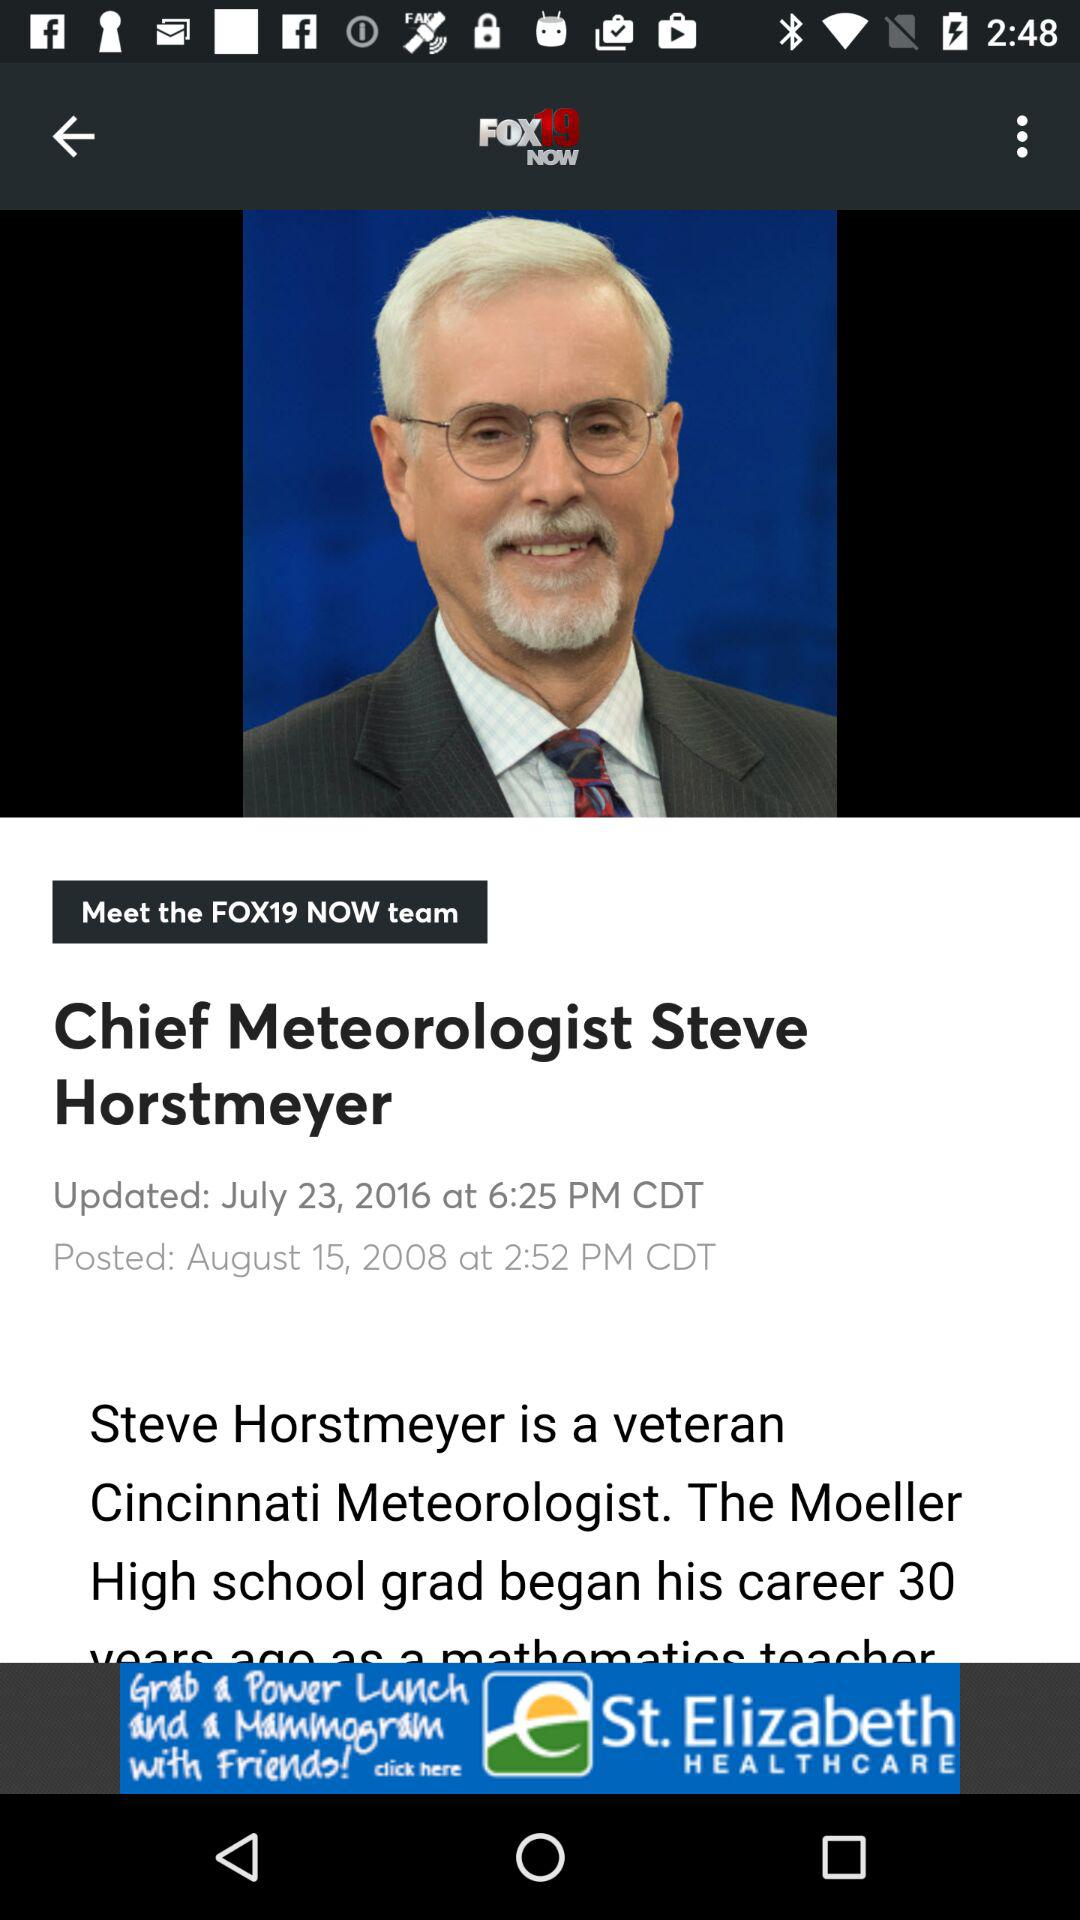On which date and time was the "Chief Meteorologist Steve Horstmeyer" news posted? The "Chief Meteorologist Steve Horstmeyer" news was posted on August 15, 2008 at 2:52 PM CDT. 